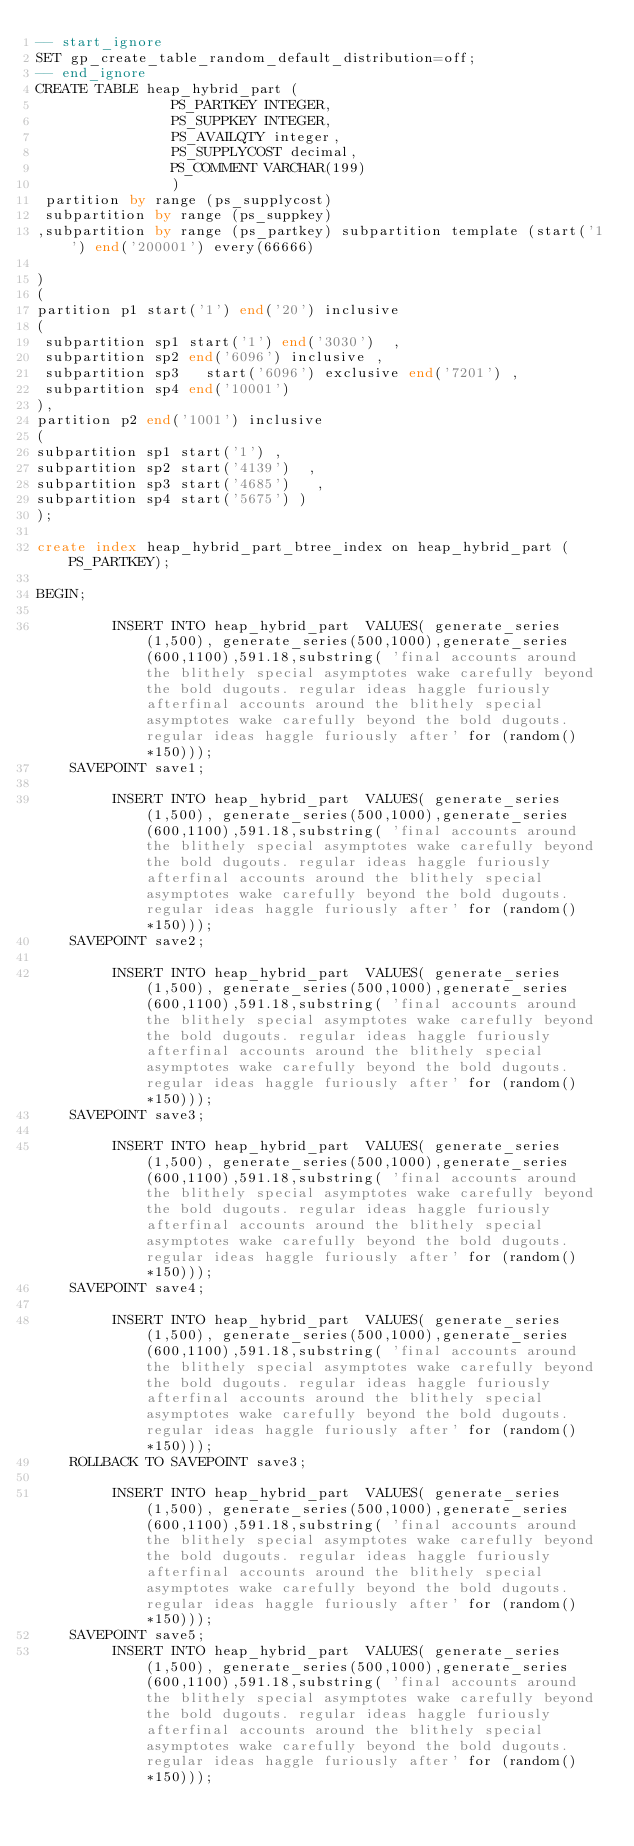Convert code to text. <code><loc_0><loc_0><loc_500><loc_500><_SQL_>-- start_ignore
SET gp_create_table_random_default_distribution=off;
-- end_ignore
CREATE TABLE heap_hybrid_part (
                PS_PARTKEY INTEGER,
                PS_SUPPKEY INTEGER,
                PS_AVAILQTY integer,
                PS_SUPPLYCOST decimal,
                PS_COMMENT VARCHAR(199)
                )   
 partition by range (ps_supplycost) 
 subpartition by range (ps_suppkey)
,subpartition by range (ps_partkey) subpartition template (start('1') end('200001') every(66666)

)
(
partition p1 start('1') end('20') inclusive
(
 subpartition sp1 start('1') end('3030')  ,
 subpartition sp2 end('6096') inclusive ,
 subpartition sp3   start('6096') exclusive end('7201') ,
 subpartition sp4 end('10001')  
), 
partition p2 end('1001') inclusive
(
subpartition sp1 start('1') ,    
subpartition sp2 start('4139')  ,
subpartition sp3 start('4685')   ,   
subpartition sp4 start('5675') )
);

create index heap_hybrid_part_btree_index on heap_hybrid_part (PS_PARTKEY);

BEGIN;
     
         INSERT INTO heap_hybrid_part  VALUES( generate_series(1,500), generate_series(500,1000),generate_series(600,1100),591.18,substring( 'final accounts around the blithely special asymptotes wake carefully beyond the bold dugouts. regular ideas haggle furiously afterfinal accounts around the blithely special asymptotes wake carefully beyond the bold dugouts. regular ideas haggle furiously after' for (random()*150)));
    SAVEPOINT save1;

         INSERT INTO heap_hybrid_part  VALUES( generate_series(1,500), generate_series(500,1000),generate_series(600,1100),591.18,substring( 'final accounts around the blithely special asymptotes wake carefully beyond the bold dugouts. regular ideas haggle furiously afterfinal accounts around the blithely special asymptotes wake carefully beyond the bold dugouts. regular ideas haggle furiously after' for (random()*150)));
    SAVEPOINT save2;

         INSERT INTO heap_hybrid_part  VALUES( generate_series(1,500), generate_series(500,1000),generate_series(600,1100),591.18,substring( 'final accounts around the blithely special asymptotes wake carefully beyond the bold dugouts. regular ideas haggle furiously afterfinal accounts around the blithely special asymptotes wake carefully beyond the bold dugouts. regular ideas haggle furiously after' for (random()*150)));
    SAVEPOINT save3;

         INSERT INTO heap_hybrid_part  VALUES( generate_series(1,500), generate_series(500,1000),generate_series(600,1100),591.18,substring( 'final accounts around the blithely special asymptotes wake carefully beyond the bold dugouts. regular ideas haggle furiously afterfinal accounts around the blithely special asymptotes wake carefully beyond the bold dugouts. regular ideas haggle furiously after' for (random()*150)));
    SAVEPOINT save4;

         INSERT INTO heap_hybrid_part  VALUES( generate_series(1,500), generate_series(500,1000),generate_series(600,1100),591.18,substring( 'final accounts around the blithely special asymptotes wake carefully beyond the bold dugouts. regular ideas haggle furiously afterfinal accounts around the blithely special asymptotes wake carefully beyond the bold dugouts. regular ideas haggle furiously after' for (random()*150)));
    ROLLBACK TO SAVEPOINT save3;

         INSERT INTO heap_hybrid_part  VALUES( generate_series(1,500), generate_series(500,1000),generate_series(600,1100),591.18,substring( 'final accounts around the blithely special asymptotes wake carefully beyond the bold dugouts. regular ideas haggle furiously afterfinal accounts around the blithely special asymptotes wake carefully beyond the bold dugouts. regular ideas haggle furiously after' for (random()*150)));
    SAVEPOINT save5;
         INSERT INTO heap_hybrid_part  VALUES( generate_series(1,500), generate_series(500,1000),generate_series(600,1100),591.18,substring( 'final accounts around the blithely special asymptotes wake carefully beyond the bold dugouts. regular ideas haggle furiously afterfinal accounts around the blithely special asymptotes wake carefully beyond the bold dugouts. regular ideas haggle furiously after' for (random()*150)));</code> 